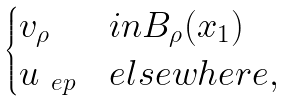Convert formula to latex. <formula><loc_0><loc_0><loc_500><loc_500>\begin{cases} v _ { \rho } & i n B _ { \rho } ( x _ { 1 } ) \\ u _ { \ e p } & e l s e w h e r e , \end{cases}</formula> 